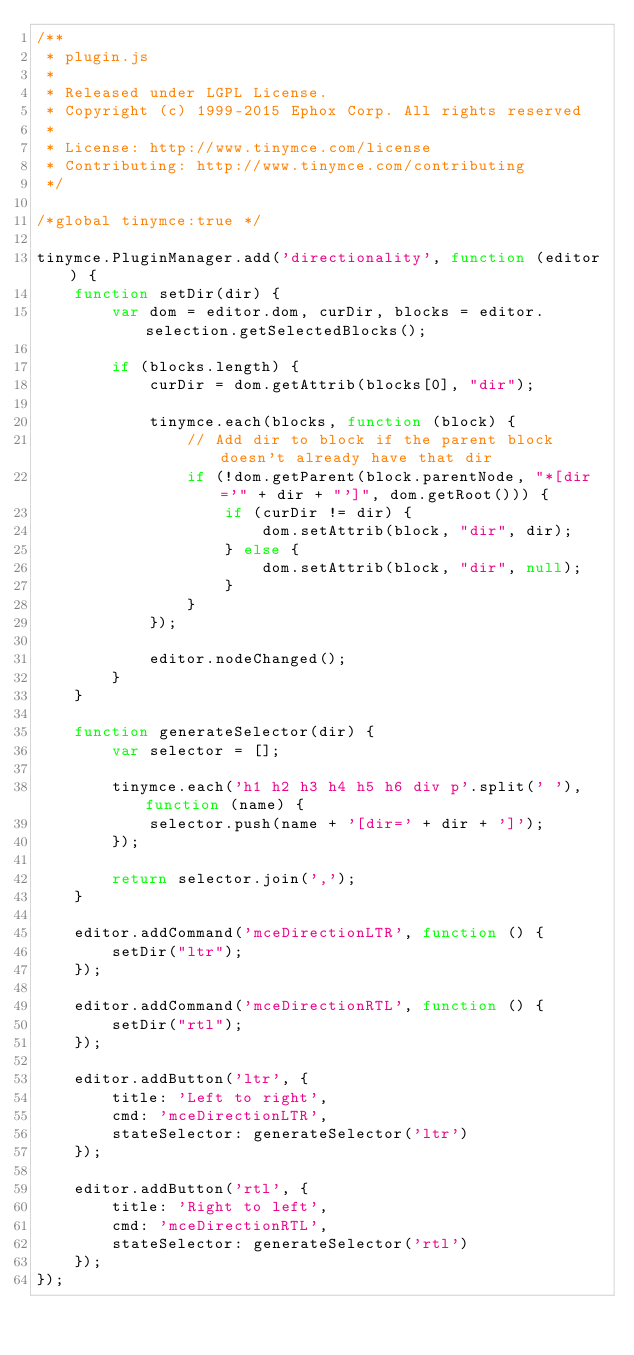Convert code to text. <code><loc_0><loc_0><loc_500><loc_500><_JavaScript_>/**
 * plugin.js
 *
 * Released under LGPL License.
 * Copyright (c) 1999-2015 Ephox Corp. All rights reserved
 *
 * License: http://www.tinymce.com/license
 * Contributing: http://www.tinymce.com/contributing
 */

/*global tinymce:true */

tinymce.PluginManager.add('directionality', function (editor) {
    function setDir(dir) {
        var dom = editor.dom, curDir, blocks = editor.selection.getSelectedBlocks();

        if (blocks.length) {
            curDir = dom.getAttrib(blocks[0], "dir");

            tinymce.each(blocks, function (block) {
                // Add dir to block if the parent block doesn't already have that dir
                if (!dom.getParent(block.parentNode, "*[dir='" + dir + "']", dom.getRoot())) {
                    if (curDir != dir) {
                        dom.setAttrib(block, "dir", dir);
                    } else {
                        dom.setAttrib(block, "dir", null);
                    }
                }
            });

            editor.nodeChanged();
        }
    }

    function generateSelector(dir) {
        var selector = [];

        tinymce.each('h1 h2 h3 h4 h5 h6 div p'.split(' '), function (name) {
            selector.push(name + '[dir=' + dir + ']');
        });

        return selector.join(',');
    }

    editor.addCommand('mceDirectionLTR', function () {
        setDir("ltr");
    });

    editor.addCommand('mceDirectionRTL', function () {
        setDir("rtl");
    });

    editor.addButton('ltr', {
        title: 'Left to right',
        cmd: 'mceDirectionLTR',
        stateSelector: generateSelector('ltr')
    });

    editor.addButton('rtl', {
        title: 'Right to left',
        cmd: 'mceDirectionRTL',
        stateSelector: generateSelector('rtl')
    });
});</code> 